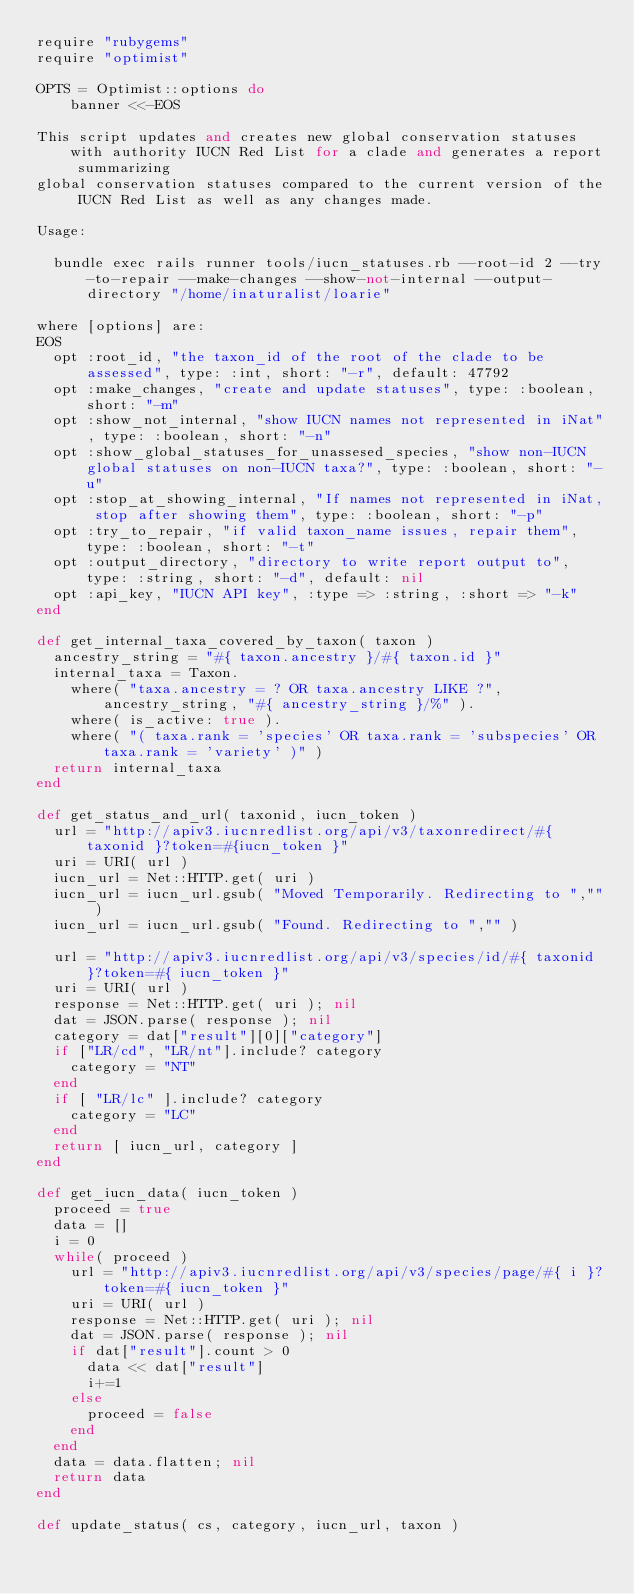Convert code to text. <code><loc_0><loc_0><loc_500><loc_500><_Ruby_>require "rubygems"
require "optimist"

OPTS = Optimist::options do
    banner <<-EOS

This script updates and creates new global conservation statuses with authority IUCN Red List for a clade and generates a report summarizing
global conservation statuses compared to the current version of the IUCN Red List as well as any changes made.

Usage:

  bundle exec rails runner tools/iucn_statuses.rb --root-id 2 --try-to-repair --make-changes --show-not-internal --output-directory "/home/inaturalist/loarie"

where [options] are:
EOS
  opt :root_id, "the taxon_id of the root of the clade to be assessed", type: :int, short: "-r", default: 47792
  opt :make_changes, "create and update statuses", type: :boolean, short: "-m"
  opt :show_not_internal, "show IUCN names not represented in iNat", type: :boolean, short: "-n"
  opt :show_global_statuses_for_unassesed_species, "show non-IUCN global statuses on non-IUCN taxa?", type: :boolean, short: "-u"
  opt :stop_at_showing_internal, "If names not represented in iNat, stop after showing them", type: :boolean, short: "-p"
  opt :try_to_repair, "if valid taxon_name issues, repair them", type: :boolean, short: "-t"
  opt :output_directory, "directory to write report output to", type: :string, short: "-d", default: nil
  opt :api_key, "IUCN API key", :type => :string, :short => "-k"
end

def get_internal_taxa_covered_by_taxon( taxon )
  ancestry_string = "#{ taxon.ancestry }/#{ taxon.id }"
  internal_taxa = Taxon.
    where( "taxa.ancestry = ? OR taxa.ancestry LIKE ?", ancestry_string, "#{ ancestry_string }/%" ).
    where( is_active: true ).
    where( "( taxa.rank = 'species' OR taxa.rank = 'subspecies' OR taxa.rank = 'variety' )" )
  return internal_taxa
end

def get_status_and_url( taxonid, iucn_token )
  url = "http://apiv3.iucnredlist.org/api/v3/taxonredirect/#{ taxonid }?token=#{iucn_token }"
  uri = URI( url )
  iucn_url = Net::HTTP.get( uri )
  iucn_url = iucn_url.gsub( "Moved Temporarily. Redirecting to ","" )
  iucn_url = iucn_url.gsub( "Found. Redirecting to ","" )
  
  url = "http://apiv3.iucnredlist.org/api/v3/species/id/#{ taxonid }?token=#{ iucn_token }"
  uri = URI( url )
  response = Net::HTTP.get( uri ); nil
  dat = JSON.parse( response ); nil
  category = dat["result"][0]["category"]
  if ["LR/cd", "LR/nt"].include? category
    category = "NT"
  end
  if [ "LR/lc" ].include? category
    category = "LC"
  end
  return [ iucn_url, category ]
end

def get_iucn_data( iucn_token )
  proceed = true
  data = []
  i = 0
  while( proceed )
    url = "http://apiv3.iucnredlist.org/api/v3/species/page/#{ i }?token=#{ iucn_token }"
    uri = URI( url )
    response = Net::HTTP.get( uri ); nil
    dat = JSON.parse( response ); nil
    if dat["result"].count > 0
      data << dat["result"]
      i+=1
    else
      proceed = false
    end
  end
  data = data.flatten; nil
  return data
end

def update_status( cs, category, iucn_url, taxon )</code> 